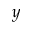Convert formula to latex. <formula><loc_0><loc_0><loc_500><loc_500>y</formula> 